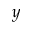Convert formula to latex. <formula><loc_0><loc_0><loc_500><loc_500>y</formula> 